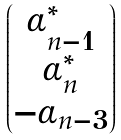Convert formula to latex. <formula><loc_0><loc_0><loc_500><loc_500>\begin{pmatrix} \alpha _ { n - 1 } ^ { \ast } \\ \alpha _ { n } ^ { \ast } \\ - \alpha _ { n - 3 } \end{pmatrix}</formula> 